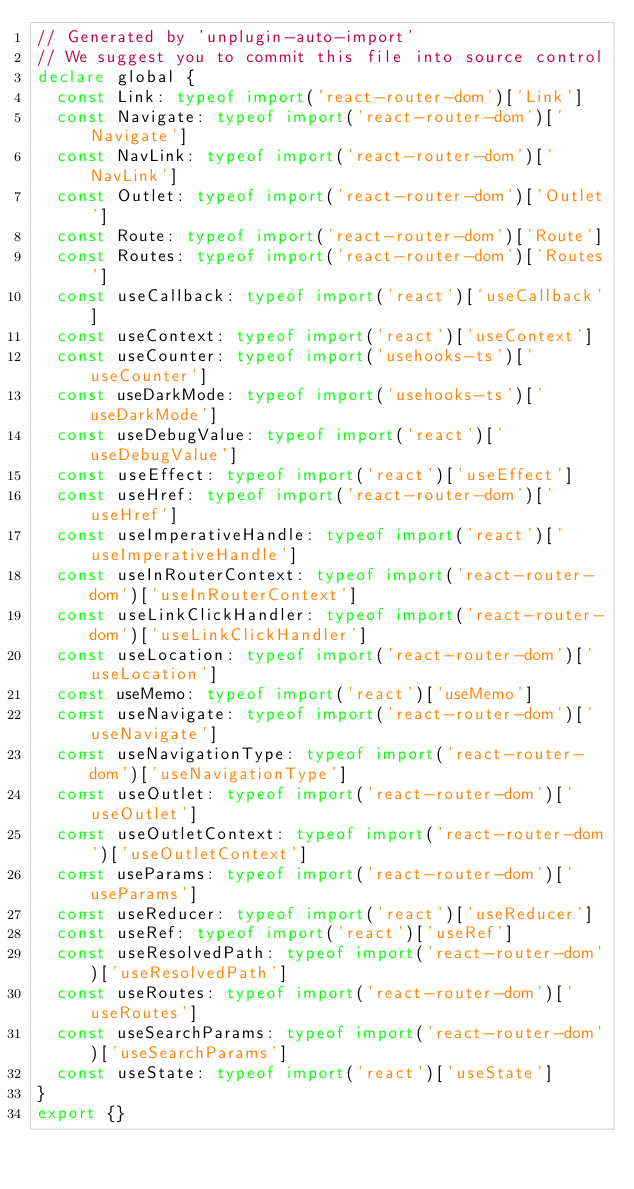<code> <loc_0><loc_0><loc_500><loc_500><_TypeScript_>// Generated by 'unplugin-auto-import'
// We suggest you to commit this file into source control
declare global {
  const Link: typeof import('react-router-dom')['Link']
  const Navigate: typeof import('react-router-dom')['Navigate']
  const NavLink: typeof import('react-router-dom')['NavLink']
  const Outlet: typeof import('react-router-dom')['Outlet']
  const Route: typeof import('react-router-dom')['Route']
  const Routes: typeof import('react-router-dom')['Routes']
  const useCallback: typeof import('react')['useCallback']
  const useContext: typeof import('react')['useContext']
  const useCounter: typeof import('usehooks-ts')['useCounter']
  const useDarkMode: typeof import('usehooks-ts')['useDarkMode']
  const useDebugValue: typeof import('react')['useDebugValue']
  const useEffect: typeof import('react')['useEffect']
  const useHref: typeof import('react-router-dom')['useHref']
  const useImperativeHandle: typeof import('react')['useImperativeHandle']
  const useInRouterContext: typeof import('react-router-dom')['useInRouterContext']
  const useLinkClickHandler: typeof import('react-router-dom')['useLinkClickHandler']
  const useLocation: typeof import('react-router-dom')['useLocation']
  const useMemo: typeof import('react')['useMemo']
  const useNavigate: typeof import('react-router-dom')['useNavigate']
  const useNavigationType: typeof import('react-router-dom')['useNavigationType']
  const useOutlet: typeof import('react-router-dom')['useOutlet']
  const useOutletContext: typeof import('react-router-dom')['useOutletContext']
  const useParams: typeof import('react-router-dom')['useParams']
  const useReducer: typeof import('react')['useReducer']
  const useRef: typeof import('react')['useRef']
  const useResolvedPath: typeof import('react-router-dom')['useResolvedPath']
  const useRoutes: typeof import('react-router-dom')['useRoutes']
  const useSearchParams: typeof import('react-router-dom')['useSearchParams']
  const useState: typeof import('react')['useState']
}
export {}
</code> 